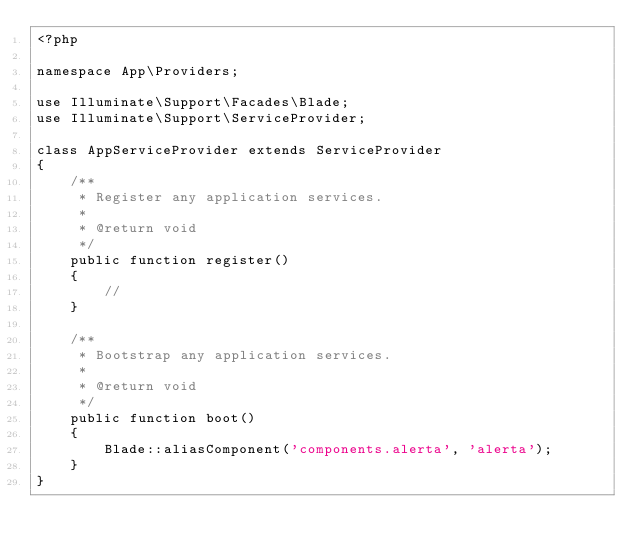Convert code to text. <code><loc_0><loc_0><loc_500><loc_500><_PHP_><?php

namespace App\Providers;

use Illuminate\Support\Facades\Blade;
use Illuminate\Support\ServiceProvider;

class AppServiceProvider extends ServiceProvider
{
    /**
     * Register any application services.
     *
     * @return void
     */
    public function register()
    {
        //
    }

    /**
     * Bootstrap any application services.
     *
     * @return void
     */
    public function boot()
    {
        Blade::aliasComponent('components.alerta', 'alerta');
    }
}
</code> 